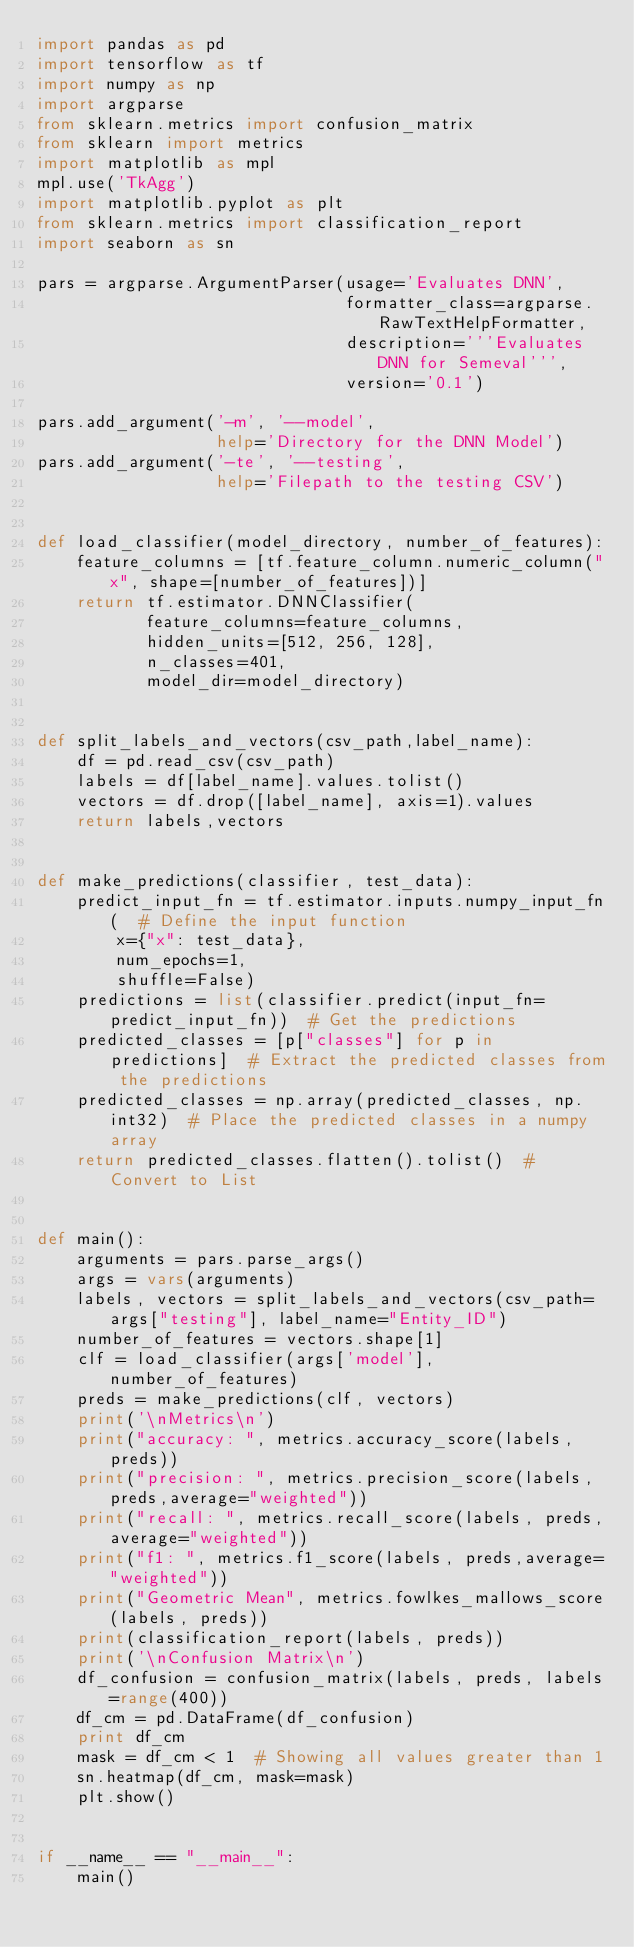<code> <loc_0><loc_0><loc_500><loc_500><_Python_>import pandas as pd
import tensorflow as tf
import numpy as np
import argparse
from sklearn.metrics import confusion_matrix
from sklearn import metrics
import matplotlib as mpl
mpl.use('TkAgg')
import matplotlib.pyplot as plt
from sklearn.metrics import classification_report
import seaborn as sn

pars = argparse.ArgumentParser(usage='Evaluates DNN',
                               formatter_class=argparse.RawTextHelpFormatter,
                               description='''Evaluates DNN for Semeval''',
                               version='0.1')

pars.add_argument('-m', '--model',
                  help='Directory for the DNN Model')
pars.add_argument('-te', '--testing',
                  help='Filepath to the testing CSV')


def load_classifier(model_directory, number_of_features):
    feature_columns = [tf.feature_column.numeric_column("x", shape=[number_of_features])]
    return tf.estimator.DNNClassifier(
           feature_columns=feature_columns,
           hidden_units=[512, 256, 128],
           n_classes=401,
           model_dir=model_directory)


def split_labels_and_vectors(csv_path,label_name):
    df = pd.read_csv(csv_path)
    labels = df[label_name].values.tolist()
    vectors = df.drop([label_name], axis=1).values
    return labels,vectors


def make_predictions(classifier, test_data):
    predict_input_fn = tf.estimator.inputs.numpy_input_fn(  # Define the input function
        x={"x": test_data},
        num_epochs=1,
        shuffle=False)
    predictions = list(classifier.predict(input_fn=predict_input_fn))  # Get the predictions
    predicted_classes = [p["classes"] for p in predictions]  # Extract the predicted classes from the predictions
    predicted_classes = np.array(predicted_classes, np.int32)  # Place the predicted classes in a numpy array
    return predicted_classes.flatten().tolist()  # Convert to List


def main():
    arguments = pars.parse_args()
    args = vars(arguments)
    labels, vectors = split_labels_and_vectors(csv_path=args["testing"], label_name="Entity_ID")
    number_of_features = vectors.shape[1]
    clf = load_classifier(args['model'], number_of_features)
    preds = make_predictions(clf, vectors)
    print('\nMetrics\n')
    print("accuracy: ", metrics.accuracy_score(labels, preds))
    print("precision: ", metrics.precision_score(labels, preds,average="weighted"))
    print("recall: ", metrics.recall_score(labels, preds,average="weighted"))
    print("f1: ", metrics.f1_score(labels, preds,average="weighted"))
    print("Geometric Mean", metrics.fowlkes_mallows_score(labels, preds))
    print(classification_report(labels, preds))
    print('\nConfusion Matrix\n')
    df_confusion = confusion_matrix(labels, preds, labels=range(400))
    df_cm = pd.DataFrame(df_confusion)
    print df_cm
    mask = df_cm < 1  # Showing all values greater than 1
    sn.heatmap(df_cm, mask=mask)
    plt.show()


if __name__ == "__main__":
    main()

</code> 